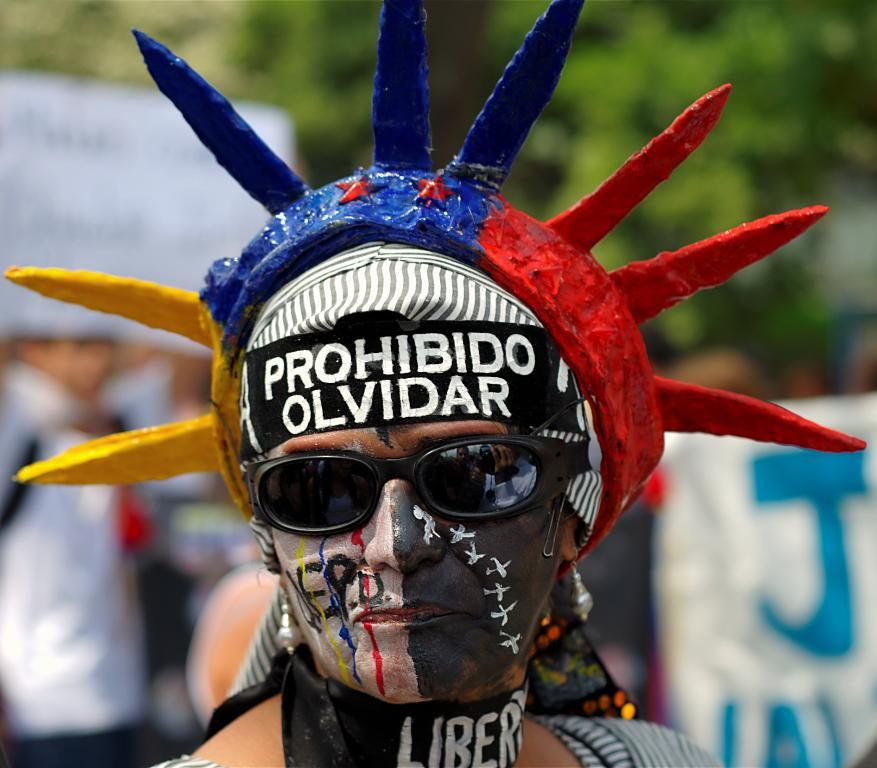What can be seen in the image? There is a person in the image. What is the person wearing on their head? The person is wearing a cap. What type of eyewear is the person wearing? The person is wearing goggles. Can you describe the person's appearance? The person has paint on their face. What type of prison is depicted in the image? There is no prison present in the image; it features a person wearing a cap, goggles, and paint on their face. What kind of toothpaste is the person using in the image? There is no toothpaste present in the image. 